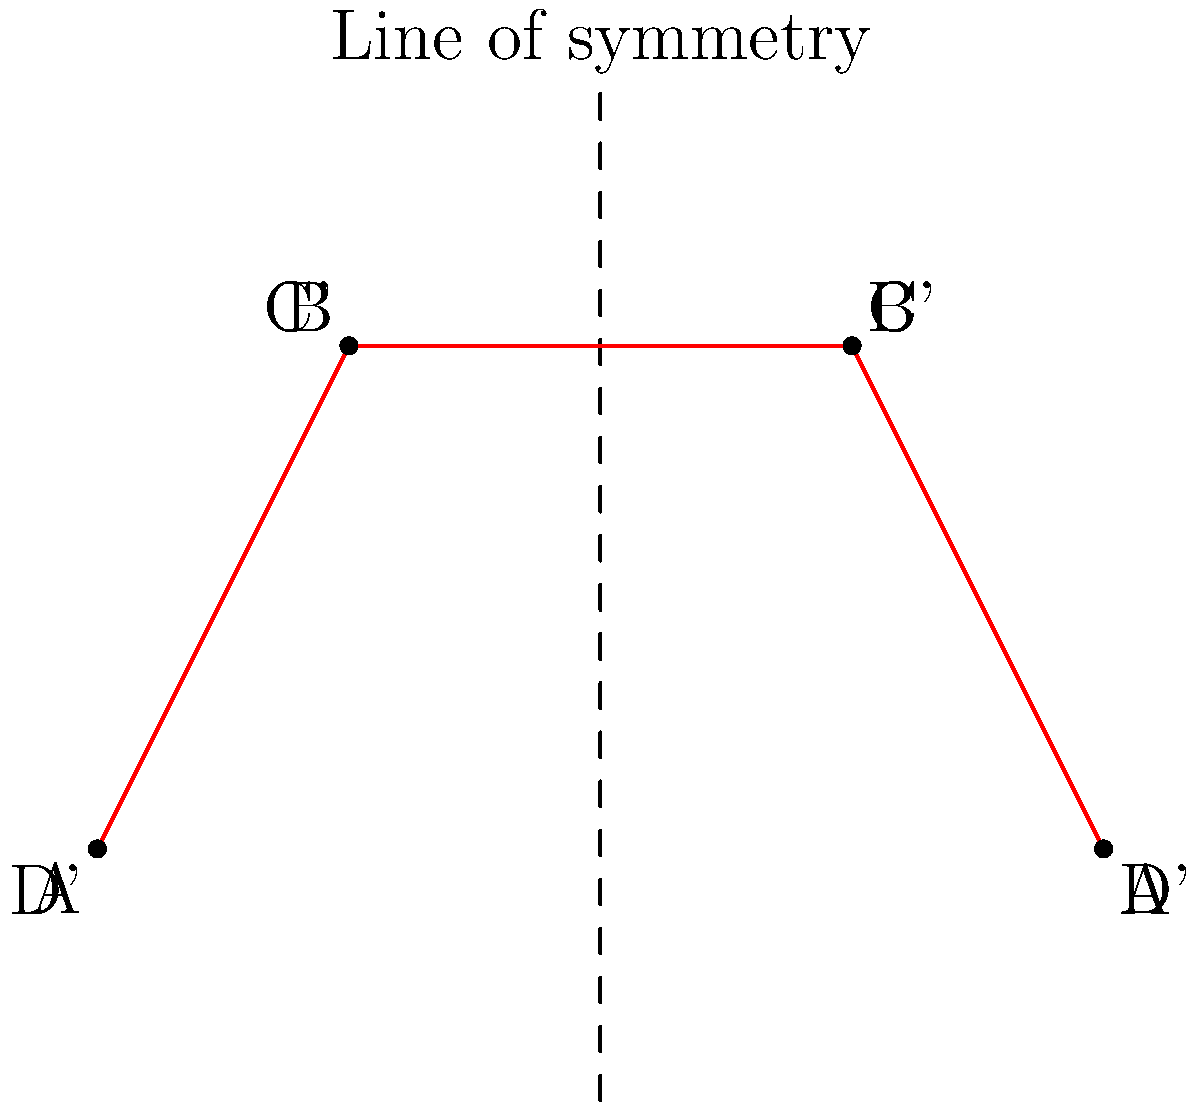The Ilkeston Flyer bus route is represented by the blue line ABCD in the diagram. If this route is reflected across the vertical line of symmetry shown, what will be the coordinates of point C' (the reflection of point C) in the new route? To find the coordinates of point C' after reflection, we can follow these steps:

1. Identify the original coordinates of point C:
   Point C is at (3, 2)

2. Identify the equation of the line of symmetry:
   The line of symmetry is a vertical line at x = 2

3. Apply the reflection formula:
   For a vertical line of reflection at x = a, the reflection of a point (x, y) is (2a - x, y)
   In this case, a = 2

4. Calculate the new x-coordinate:
   x' = 2a - x = 2(2) - 3 = 4 - 3 = 1

5. The y-coordinate remains unchanged in a reflection over a vertical line:
   y' = y = 2

Therefore, the coordinates of point C' after reflection are (1, 2).
Answer: (1, 2) 